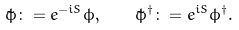<formula> <loc_0><loc_0><loc_500><loc_500>\tilde { \phi } \colon = e ^ { - i S } \phi , \quad \tilde { \phi } ^ { \dagger } \colon = e ^ { i S } \phi ^ { \dagger } .</formula> 